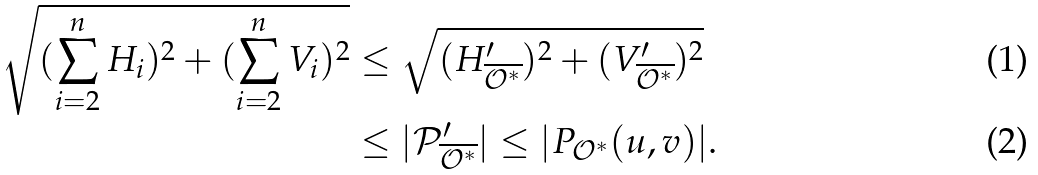<formula> <loc_0><loc_0><loc_500><loc_500>\sqrt { ( \sum _ { i = 2 } ^ { n } H _ { i } ) ^ { 2 } + ( \sum _ { i = 2 } ^ { n } V _ { i } ) ^ { 2 } } & \leq \sqrt { ( H _ { \overline { \mathcal { O } ^ { * } } } ^ { \prime } ) ^ { 2 } + ( V _ { \overline { \mathcal { O } ^ { * } } } ^ { \prime } ) ^ { 2 } } \\ & \leq | \mathcal { P } _ { \overline { \mathcal { O } ^ { * } } } ^ { \prime } | \leq | P _ { \mathcal { O } ^ { * } } ( u , v ) | .</formula> 